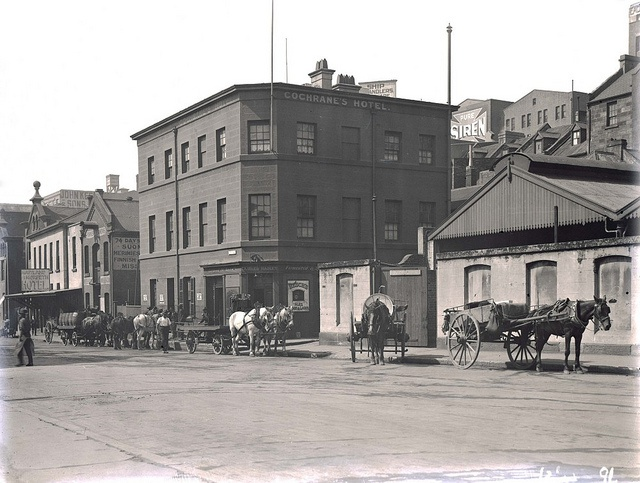Describe the objects in this image and their specific colors. I can see horse in white, black, gray, darkgray, and lightgray tones, horse in white, gray, darkgray, and black tones, horse in white, gray, black, and darkgray tones, people in white, black, gray, and darkgray tones, and horse in white, gray, darkgray, black, and lightgray tones in this image. 